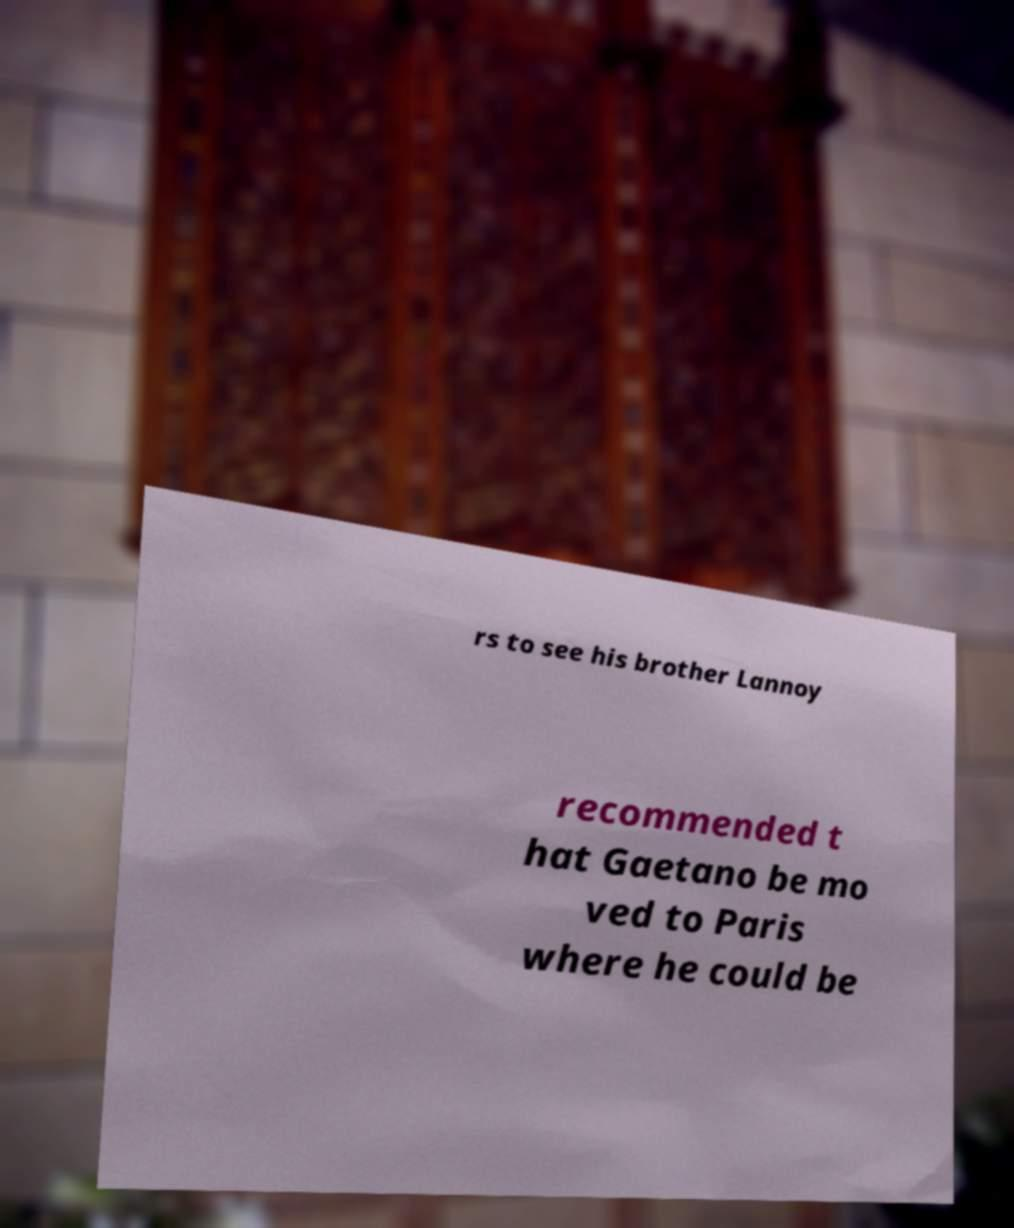Can you accurately transcribe the text from the provided image for me? rs to see his brother Lannoy recommended t hat Gaetano be mo ved to Paris where he could be 